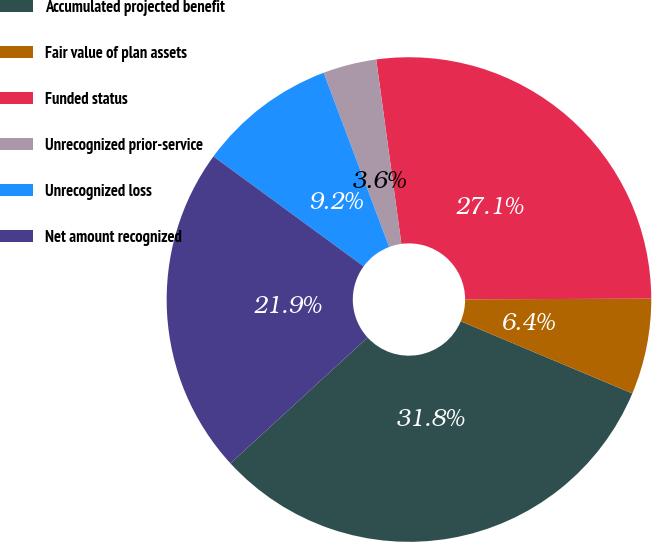Convert chart to OTSL. <chart><loc_0><loc_0><loc_500><loc_500><pie_chart><fcel>Accumulated projected benefit<fcel>Fair value of plan assets<fcel>Funded status<fcel>Unrecognized prior-service<fcel>Unrecognized loss<fcel>Net amount recognized<nl><fcel>31.85%<fcel>6.39%<fcel>27.1%<fcel>3.57%<fcel>9.22%<fcel>21.87%<nl></chart> 